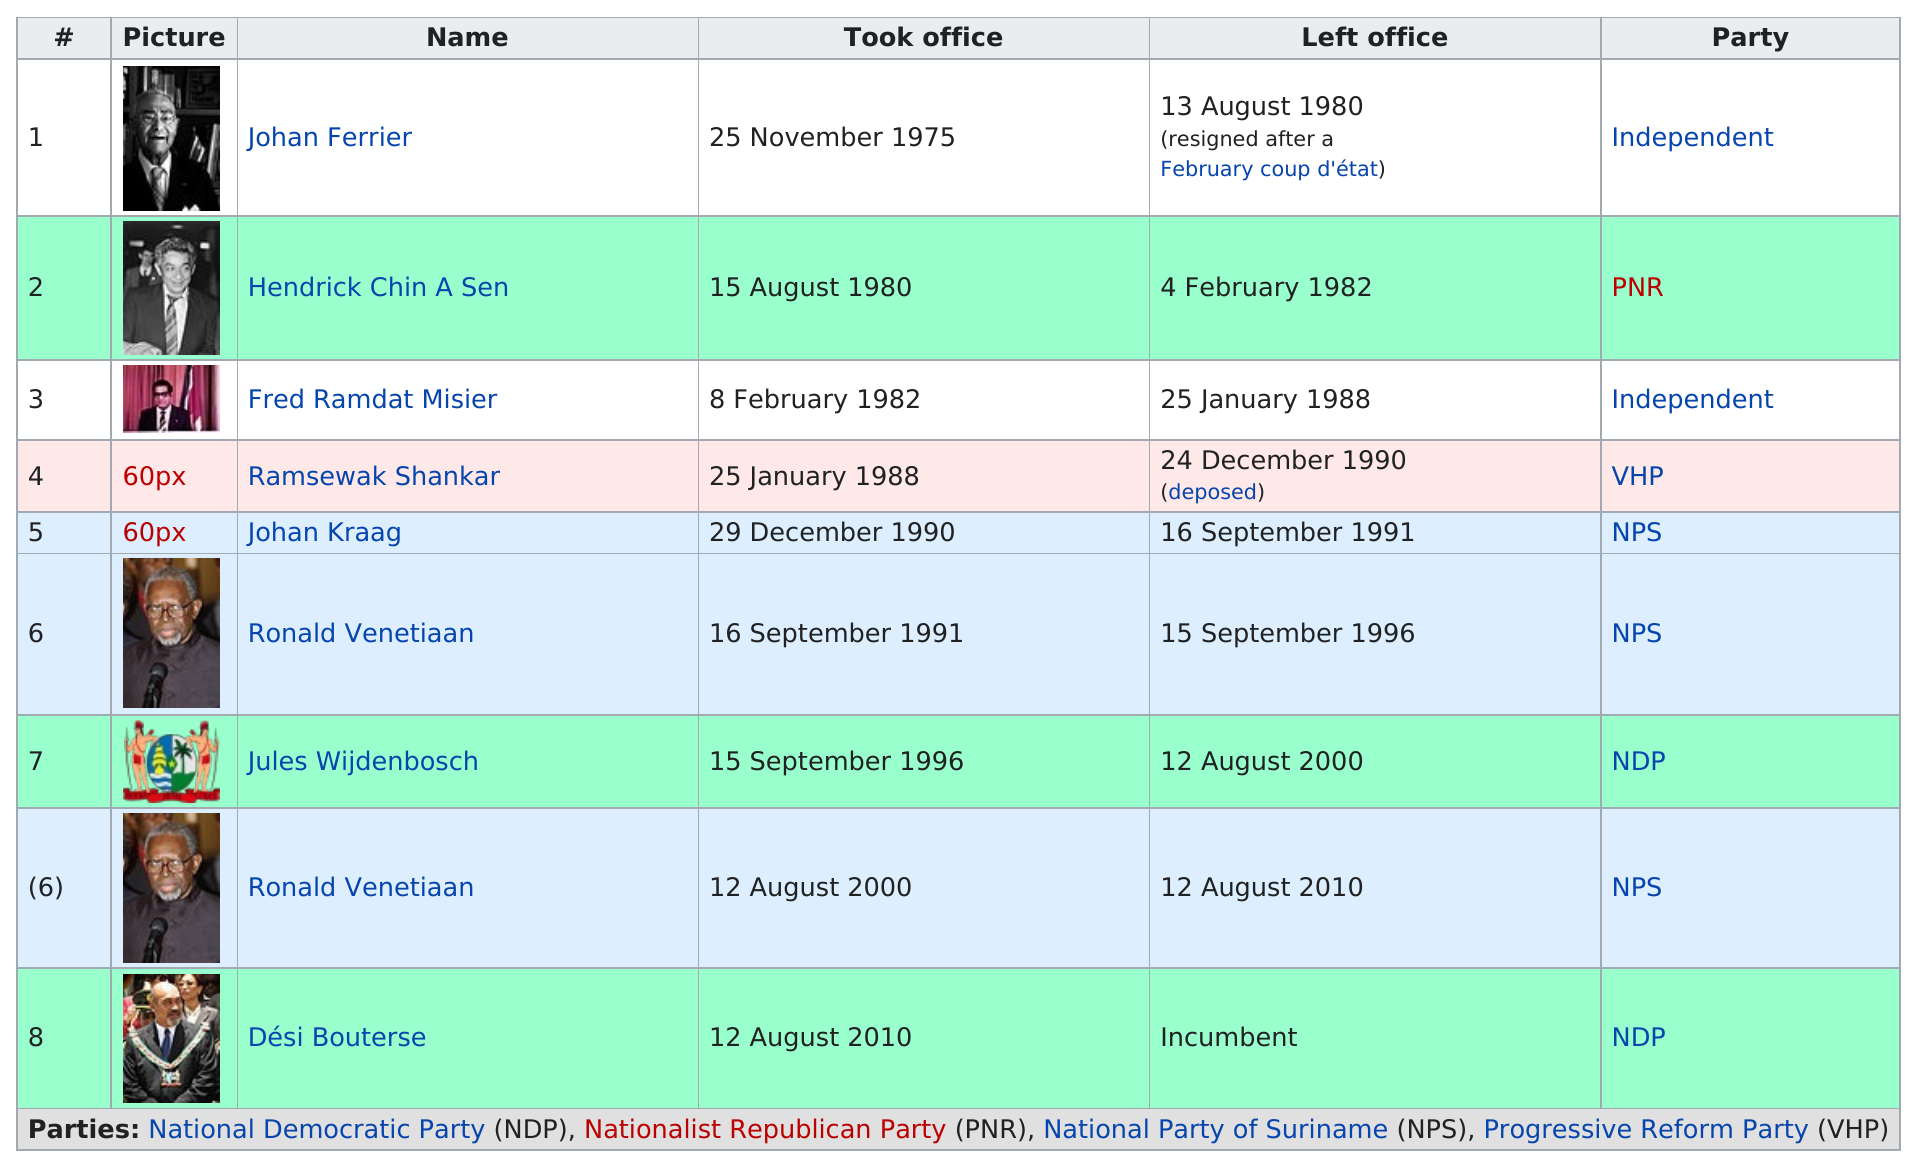Draw attention to some important aspects in this diagram. Desi Bouterse has been the President of Suriname for four years. Ronald Venetiaan was the president who served as an officer for the longest duration before Desi Bouterse. The most popular political party for presidents is the National Popular Party (NPS). Fred Ramdat Misier was an independent president who had the longest reign for an independent. 